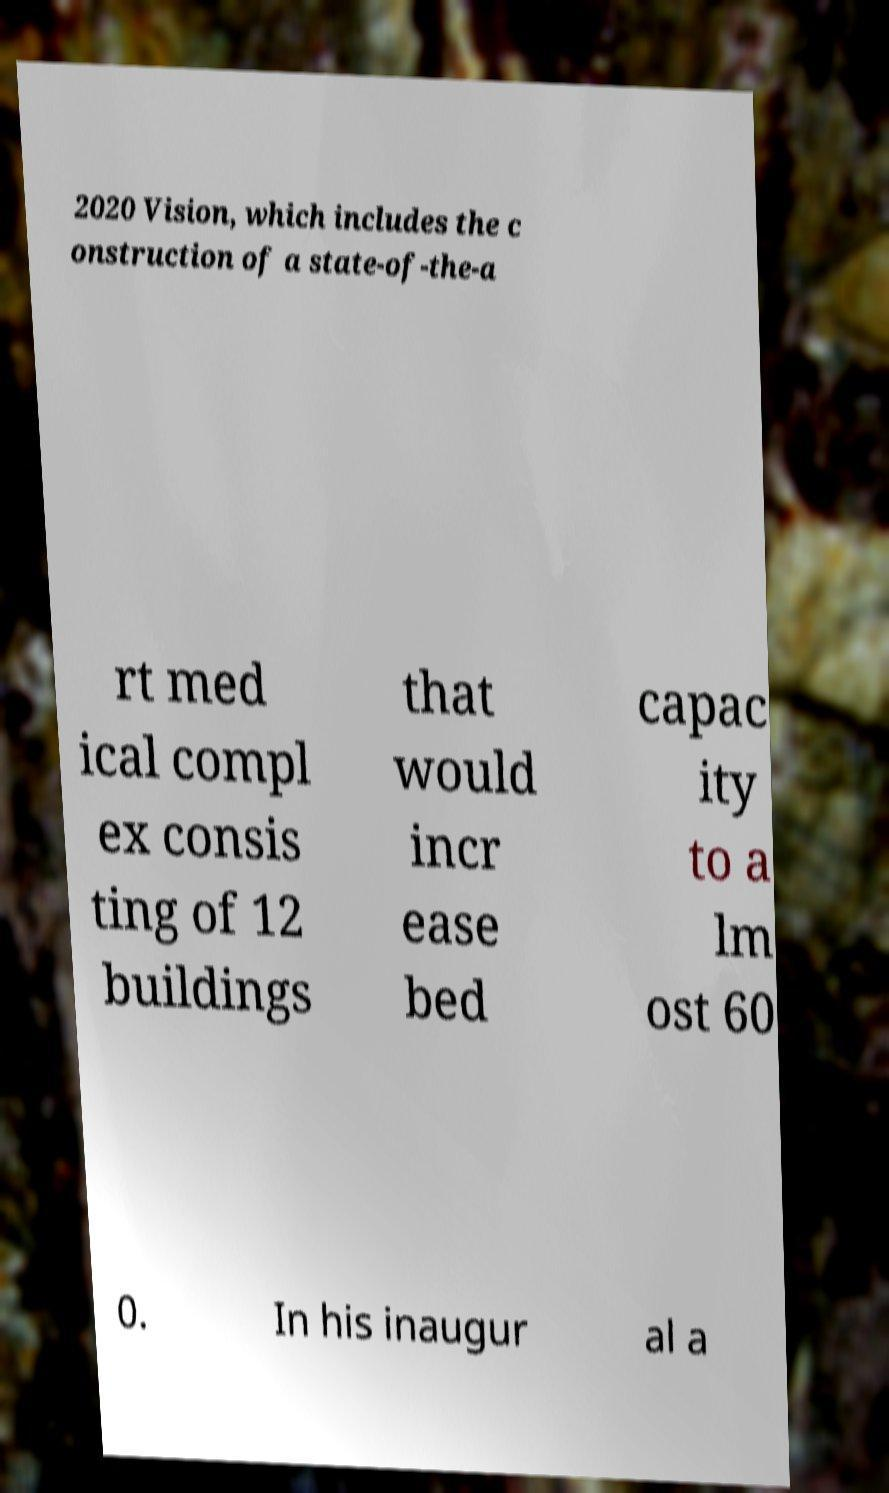Can you accurately transcribe the text from the provided image for me? 2020 Vision, which includes the c onstruction of a state-of-the-a rt med ical compl ex consis ting of 12 buildings that would incr ease bed capac ity to a lm ost 60 0. In his inaugur al a 